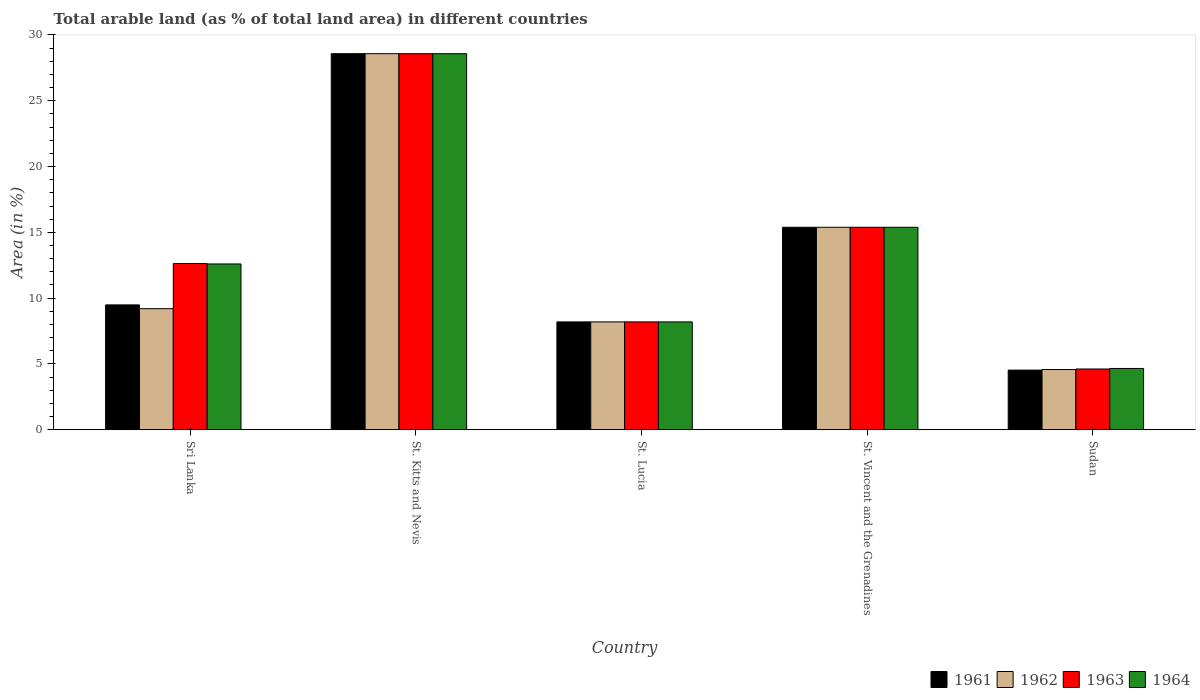How many different coloured bars are there?
Provide a succinct answer. 4. How many bars are there on the 2nd tick from the left?
Provide a succinct answer. 4. How many bars are there on the 5th tick from the right?
Provide a short and direct response. 4. What is the label of the 3rd group of bars from the left?
Provide a short and direct response. St. Lucia. What is the percentage of arable land in 1964 in Sri Lanka?
Provide a succinct answer. 12.6. Across all countries, what is the maximum percentage of arable land in 1963?
Offer a terse response. 28.57. Across all countries, what is the minimum percentage of arable land in 1962?
Your answer should be compact. 4.58. In which country was the percentage of arable land in 1964 maximum?
Provide a short and direct response. St. Kitts and Nevis. In which country was the percentage of arable land in 1962 minimum?
Your response must be concise. Sudan. What is the total percentage of arable land in 1963 in the graph?
Make the answer very short. 69.4. What is the difference between the percentage of arable land in 1962 in Sri Lanka and that in Sudan?
Give a very brief answer. 4.62. What is the difference between the percentage of arable land in 1962 in St. Lucia and the percentage of arable land in 1963 in Sudan?
Keep it short and to the point. 3.58. What is the average percentage of arable land in 1963 per country?
Ensure brevity in your answer.  13.88. What is the difference between the percentage of arable land of/in 1962 and percentage of arable land of/in 1964 in Sudan?
Keep it short and to the point. -0.08. In how many countries, is the percentage of arable land in 1963 greater than 9 %?
Keep it short and to the point. 3. What is the ratio of the percentage of arable land in 1961 in St. Vincent and the Grenadines to that in Sudan?
Offer a terse response. 3.39. Is the percentage of arable land in 1963 in St. Kitts and Nevis less than that in St. Lucia?
Offer a very short reply. No. What is the difference between the highest and the second highest percentage of arable land in 1963?
Keep it short and to the point. 15.94. What is the difference between the highest and the lowest percentage of arable land in 1963?
Give a very brief answer. 23.95. In how many countries, is the percentage of arable land in 1963 greater than the average percentage of arable land in 1963 taken over all countries?
Make the answer very short. 2. Is it the case that in every country, the sum of the percentage of arable land in 1963 and percentage of arable land in 1962 is greater than the sum of percentage of arable land in 1961 and percentage of arable land in 1964?
Your answer should be very brief. No. How many bars are there?
Give a very brief answer. 20. Are all the bars in the graph horizontal?
Provide a succinct answer. No. How many countries are there in the graph?
Make the answer very short. 5. Are the values on the major ticks of Y-axis written in scientific E-notation?
Ensure brevity in your answer.  No. Does the graph contain any zero values?
Your answer should be compact. No. Does the graph contain grids?
Provide a short and direct response. No. Where does the legend appear in the graph?
Keep it short and to the point. Bottom right. How are the legend labels stacked?
Your response must be concise. Horizontal. What is the title of the graph?
Your response must be concise. Total arable land (as % of total land area) in different countries. What is the label or title of the X-axis?
Provide a succinct answer. Country. What is the label or title of the Y-axis?
Give a very brief answer. Area (in %). What is the Area (in %) in 1961 in Sri Lanka?
Give a very brief answer. 9.49. What is the Area (in %) in 1962 in Sri Lanka?
Provide a succinct answer. 9.2. What is the Area (in %) of 1963 in Sri Lanka?
Ensure brevity in your answer.  12.63. What is the Area (in %) of 1964 in Sri Lanka?
Offer a terse response. 12.6. What is the Area (in %) of 1961 in St. Kitts and Nevis?
Keep it short and to the point. 28.57. What is the Area (in %) of 1962 in St. Kitts and Nevis?
Your answer should be compact. 28.57. What is the Area (in %) in 1963 in St. Kitts and Nevis?
Ensure brevity in your answer.  28.57. What is the Area (in %) of 1964 in St. Kitts and Nevis?
Offer a terse response. 28.57. What is the Area (in %) of 1961 in St. Lucia?
Offer a very short reply. 8.2. What is the Area (in %) in 1962 in St. Lucia?
Offer a very short reply. 8.2. What is the Area (in %) in 1963 in St. Lucia?
Give a very brief answer. 8.2. What is the Area (in %) of 1964 in St. Lucia?
Offer a terse response. 8.2. What is the Area (in %) of 1961 in St. Vincent and the Grenadines?
Ensure brevity in your answer.  15.38. What is the Area (in %) in 1962 in St. Vincent and the Grenadines?
Your response must be concise. 15.38. What is the Area (in %) of 1963 in St. Vincent and the Grenadines?
Give a very brief answer. 15.38. What is the Area (in %) in 1964 in St. Vincent and the Grenadines?
Give a very brief answer. 15.38. What is the Area (in %) of 1961 in Sudan?
Provide a succinct answer. 4.53. What is the Area (in %) in 1962 in Sudan?
Your response must be concise. 4.58. What is the Area (in %) of 1963 in Sudan?
Your answer should be very brief. 4.62. What is the Area (in %) of 1964 in Sudan?
Make the answer very short. 4.66. Across all countries, what is the maximum Area (in %) in 1961?
Ensure brevity in your answer.  28.57. Across all countries, what is the maximum Area (in %) of 1962?
Make the answer very short. 28.57. Across all countries, what is the maximum Area (in %) in 1963?
Offer a very short reply. 28.57. Across all countries, what is the maximum Area (in %) of 1964?
Your answer should be compact. 28.57. Across all countries, what is the minimum Area (in %) in 1961?
Your answer should be compact. 4.53. Across all countries, what is the minimum Area (in %) of 1962?
Keep it short and to the point. 4.58. Across all countries, what is the minimum Area (in %) of 1963?
Ensure brevity in your answer.  4.62. Across all countries, what is the minimum Area (in %) of 1964?
Your response must be concise. 4.66. What is the total Area (in %) in 1961 in the graph?
Your answer should be compact. 66.18. What is the total Area (in %) of 1962 in the graph?
Ensure brevity in your answer.  65.93. What is the total Area (in %) in 1963 in the graph?
Your answer should be compact. 69.4. What is the total Area (in %) in 1964 in the graph?
Provide a succinct answer. 69.41. What is the difference between the Area (in %) of 1961 in Sri Lanka and that in St. Kitts and Nevis?
Provide a short and direct response. -19.08. What is the difference between the Area (in %) in 1962 in Sri Lanka and that in St. Kitts and Nevis?
Offer a terse response. -19.37. What is the difference between the Area (in %) of 1963 in Sri Lanka and that in St. Kitts and Nevis?
Make the answer very short. -15.94. What is the difference between the Area (in %) of 1964 in Sri Lanka and that in St. Kitts and Nevis?
Your response must be concise. -15.97. What is the difference between the Area (in %) in 1961 in Sri Lanka and that in St. Lucia?
Provide a short and direct response. 1.29. What is the difference between the Area (in %) of 1963 in Sri Lanka and that in St. Lucia?
Offer a terse response. 4.43. What is the difference between the Area (in %) of 1964 in Sri Lanka and that in St. Lucia?
Ensure brevity in your answer.  4.4. What is the difference between the Area (in %) in 1961 in Sri Lanka and that in St. Vincent and the Grenadines?
Give a very brief answer. -5.9. What is the difference between the Area (in %) in 1962 in Sri Lanka and that in St. Vincent and the Grenadines?
Your answer should be compact. -6.18. What is the difference between the Area (in %) in 1963 in Sri Lanka and that in St. Vincent and the Grenadines?
Offer a very short reply. -2.76. What is the difference between the Area (in %) of 1964 in Sri Lanka and that in St. Vincent and the Grenadines?
Offer a terse response. -2.79. What is the difference between the Area (in %) in 1961 in Sri Lanka and that in Sudan?
Keep it short and to the point. 4.95. What is the difference between the Area (in %) of 1962 in Sri Lanka and that in Sudan?
Provide a succinct answer. 4.62. What is the difference between the Area (in %) of 1963 in Sri Lanka and that in Sudan?
Ensure brevity in your answer.  8.01. What is the difference between the Area (in %) in 1964 in Sri Lanka and that in Sudan?
Offer a terse response. 7.94. What is the difference between the Area (in %) of 1961 in St. Kitts and Nevis and that in St. Lucia?
Your response must be concise. 20.37. What is the difference between the Area (in %) of 1962 in St. Kitts and Nevis and that in St. Lucia?
Offer a very short reply. 20.37. What is the difference between the Area (in %) in 1963 in St. Kitts and Nevis and that in St. Lucia?
Offer a terse response. 20.37. What is the difference between the Area (in %) of 1964 in St. Kitts and Nevis and that in St. Lucia?
Ensure brevity in your answer.  20.37. What is the difference between the Area (in %) in 1961 in St. Kitts and Nevis and that in St. Vincent and the Grenadines?
Keep it short and to the point. 13.19. What is the difference between the Area (in %) of 1962 in St. Kitts and Nevis and that in St. Vincent and the Grenadines?
Your response must be concise. 13.19. What is the difference between the Area (in %) in 1963 in St. Kitts and Nevis and that in St. Vincent and the Grenadines?
Your answer should be very brief. 13.19. What is the difference between the Area (in %) of 1964 in St. Kitts and Nevis and that in St. Vincent and the Grenadines?
Your response must be concise. 13.19. What is the difference between the Area (in %) in 1961 in St. Kitts and Nevis and that in Sudan?
Make the answer very short. 24.04. What is the difference between the Area (in %) in 1962 in St. Kitts and Nevis and that in Sudan?
Provide a short and direct response. 23.99. What is the difference between the Area (in %) of 1963 in St. Kitts and Nevis and that in Sudan?
Offer a very short reply. 23.95. What is the difference between the Area (in %) of 1964 in St. Kitts and Nevis and that in Sudan?
Your answer should be very brief. 23.91. What is the difference between the Area (in %) of 1961 in St. Lucia and that in St. Vincent and the Grenadines?
Offer a terse response. -7.19. What is the difference between the Area (in %) in 1962 in St. Lucia and that in St. Vincent and the Grenadines?
Provide a short and direct response. -7.19. What is the difference between the Area (in %) of 1963 in St. Lucia and that in St. Vincent and the Grenadines?
Offer a terse response. -7.19. What is the difference between the Area (in %) of 1964 in St. Lucia and that in St. Vincent and the Grenadines?
Provide a succinct answer. -7.19. What is the difference between the Area (in %) of 1961 in St. Lucia and that in Sudan?
Offer a very short reply. 3.66. What is the difference between the Area (in %) of 1962 in St. Lucia and that in Sudan?
Make the answer very short. 3.62. What is the difference between the Area (in %) of 1963 in St. Lucia and that in Sudan?
Ensure brevity in your answer.  3.58. What is the difference between the Area (in %) in 1964 in St. Lucia and that in Sudan?
Give a very brief answer. 3.54. What is the difference between the Area (in %) of 1961 in St. Vincent and the Grenadines and that in Sudan?
Provide a succinct answer. 10.85. What is the difference between the Area (in %) in 1962 in St. Vincent and the Grenadines and that in Sudan?
Make the answer very short. 10.81. What is the difference between the Area (in %) of 1963 in St. Vincent and the Grenadines and that in Sudan?
Ensure brevity in your answer.  10.77. What is the difference between the Area (in %) of 1964 in St. Vincent and the Grenadines and that in Sudan?
Your response must be concise. 10.72. What is the difference between the Area (in %) of 1961 in Sri Lanka and the Area (in %) of 1962 in St. Kitts and Nevis?
Keep it short and to the point. -19.08. What is the difference between the Area (in %) in 1961 in Sri Lanka and the Area (in %) in 1963 in St. Kitts and Nevis?
Offer a very short reply. -19.08. What is the difference between the Area (in %) of 1961 in Sri Lanka and the Area (in %) of 1964 in St. Kitts and Nevis?
Your answer should be compact. -19.08. What is the difference between the Area (in %) of 1962 in Sri Lanka and the Area (in %) of 1963 in St. Kitts and Nevis?
Provide a short and direct response. -19.37. What is the difference between the Area (in %) in 1962 in Sri Lanka and the Area (in %) in 1964 in St. Kitts and Nevis?
Provide a succinct answer. -19.37. What is the difference between the Area (in %) in 1963 in Sri Lanka and the Area (in %) in 1964 in St. Kitts and Nevis?
Give a very brief answer. -15.94. What is the difference between the Area (in %) in 1961 in Sri Lanka and the Area (in %) in 1962 in St. Lucia?
Provide a succinct answer. 1.29. What is the difference between the Area (in %) in 1961 in Sri Lanka and the Area (in %) in 1963 in St. Lucia?
Make the answer very short. 1.29. What is the difference between the Area (in %) of 1961 in Sri Lanka and the Area (in %) of 1964 in St. Lucia?
Make the answer very short. 1.29. What is the difference between the Area (in %) of 1962 in Sri Lanka and the Area (in %) of 1963 in St. Lucia?
Give a very brief answer. 1. What is the difference between the Area (in %) of 1962 in Sri Lanka and the Area (in %) of 1964 in St. Lucia?
Your response must be concise. 1. What is the difference between the Area (in %) of 1963 in Sri Lanka and the Area (in %) of 1964 in St. Lucia?
Make the answer very short. 4.43. What is the difference between the Area (in %) of 1961 in Sri Lanka and the Area (in %) of 1962 in St. Vincent and the Grenadines?
Your answer should be very brief. -5.9. What is the difference between the Area (in %) in 1961 in Sri Lanka and the Area (in %) in 1963 in St. Vincent and the Grenadines?
Ensure brevity in your answer.  -5.9. What is the difference between the Area (in %) in 1961 in Sri Lanka and the Area (in %) in 1964 in St. Vincent and the Grenadines?
Your answer should be very brief. -5.9. What is the difference between the Area (in %) of 1962 in Sri Lanka and the Area (in %) of 1963 in St. Vincent and the Grenadines?
Provide a short and direct response. -6.18. What is the difference between the Area (in %) of 1962 in Sri Lanka and the Area (in %) of 1964 in St. Vincent and the Grenadines?
Ensure brevity in your answer.  -6.18. What is the difference between the Area (in %) in 1963 in Sri Lanka and the Area (in %) in 1964 in St. Vincent and the Grenadines?
Your answer should be compact. -2.76. What is the difference between the Area (in %) in 1961 in Sri Lanka and the Area (in %) in 1962 in Sudan?
Give a very brief answer. 4.91. What is the difference between the Area (in %) in 1961 in Sri Lanka and the Area (in %) in 1963 in Sudan?
Your response must be concise. 4.87. What is the difference between the Area (in %) of 1961 in Sri Lanka and the Area (in %) of 1964 in Sudan?
Ensure brevity in your answer.  4.83. What is the difference between the Area (in %) of 1962 in Sri Lanka and the Area (in %) of 1963 in Sudan?
Your answer should be very brief. 4.58. What is the difference between the Area (in %) in 1962 in Sri Lanka and the Area (in %) in 1964 in Sudan?
Offer a very short reply. 4.54. What is the difference between the Area (in %) in 1963 in Sri Lanka and the Area (in %) in 1964 in Sudan?
Provide a succinct answer. 7.97. What is the difference between the Area (in %) of 1961 in St. Kitts and Nevis and the Area (in %) of 1962 in St. Lucia?
Give a very brief answer. 20.37. What is the difference between the Area (in %) of 1961 in St. Kitts and Nevis and the Area (in %) of 1963 in St. Lucia?
Offer a very short reply. 20.37. What is the difference between the Area (in %) of 1961 in St. Kitts and Nevis and the Area (in %) of 1964 in St. Lucia?
Keep it short and to the point. 20.37. What is the difference between the Area (in %) in 1962 in St. Kitts and Nevis and the Area (in %) in 1963 in St. Lucia?
Your answer should be very brief. 20.37. What is the difference between the Area (in %) of 1962 in St. Kitts and Nevis and the Area (in %) of 1964 in St. Lucia?
Make the answer very short. 20.37. What is the difference between the Area (in %) of 1963 in St. Kitts and Nevis and the Area (in %) of 1964 in St. Lucia?
Keep it short and to the point. 20.37. What is the difference between the Area (in %) in 1961 in St. Kitts and Nevis and the Area (in %) in 1962 in St. Vincent and the Grenadines?
Offer a terse response. 13.19. What is the difference between the Area (in %) in 1961 in St. Kitts and Nevis and the Area (in %) in 1963 in St. Vincent and the Grenadines?
Keep it short and to the point. 13.19. What is the difference between the Area (in %) of 1961 in St. Kitts and Nevis and the Area (in %) of 1964 in St. Vincent and the Grenadines?
Offer a terse response. 13.19. What is the difference between the Area (in %) of 1962 in St. Kitts and Nevis and the Area (in %) of 1963 in St. Vincent and the Grenadines?
Your answer should be very brief. 13.19. What is the difference between the Area (in %) of 1962 in St. Kitts and Nevis and the Area (in %) of 1964 in St. Vincent and the Grenadines?
Provide a succinct answer. 13.19. What is the difference between the Area (in %) of 1963 in St. Kitts and Nevis and the Area (in %) of 1964 in St. Vincent and the Grenadines?
Offer a very short reply. 13.19. What is the difference between the Area (in %) in 1961 in St. Kitts and Nevis and the Area (in %) in 1962 in Sudan?
Provide a succinct answer. 23.99. What is the difference between the Area (in %) in 1961 in St. Kitts and Nevis and the Area (in %) in 1963 in Sudan?
Your answer should be very brief. 23.95. What is the difference between the Area (in %) in 1961 in St. Kitts and Nevis and the Area (in %) in 1964 in Sudan?
Keep it short and to the point. 23.91. What is the difference between the Area (in %) of 1962 in St. Kitts and Nevis and the Area (in %) of 1963 in Sudan?
Your answer should be very brief. 23.95. What is the difference between the Area (in %) of 1962 in St. Kitts and Nevis and the Area (in %) of 1964 in Sudan?
Provide a short and direct response. 23.91. What is the difference between the Area (in %) of 1963 in St. Kitts and Nevis and the Area (in %) of 1964 in Sudan?
Ensure brevity in your answer.  23.91. What is the difference between the Area (in %) of 1961 in St. Lucia and the Area (in %) of 1962 in St. Vincent and the Grenadines?
Make the answer very short. -7.19. What is the difference between the Area (in %) in 1961 in St. Lucia and the Area (in %) in 1963 in St. Vincent and the Grenadines?
Keep it short and to the point. -7.19. What is the difference between the Area (in %) in 1961 in St. Lucia and the Area (in %) in 1964 in St. Vincent and the Grenadines?
Your response must be concise. -7.19. What is the difference between the Area (in %) in 1962 in St. Lucia and the Area (in %) in 1963 in St. Vincent and the Grenadines?
Provide a succinct answer. -7.19. What is the difference between the Area (in %) of 1962 in St. Lucia and the Area (in %) of 1964 in St. Vincent and the Grenadines?
Give a very brief answer. -7.19. What is the difference between the Area (in %) of 1963 in St. Lucia and the Area (in %) of 1964 in St. Vincent and the Grenadines?
Make the answer very short. -7.19. What is the difference between the Area (in %) in 1961 in St. Lucia and the Area (in %) in 1962 in Sudan?
Keep it short and to the point. 3.62. What is the difference between the Area (in %) of 1961 in St. Lucia and the Area (in %) of 1963 in Sudan?
Make the answer very short. 3.58. What is the difference between the Area (in %) in 1961 in St. Lucia and the Area (in %) in 1964 in Sudan?
Provide a succinct answer. 3.54. What is the difference between the Area (in %) of 1962 in St. Lucia and the Area (in %) of 1963 in Sudan?
Ensure brevity in your answer.  3.58. What is the difference between the Area (in %) of 1962 in St. Lucia and the Area (in %) of 1964 in Sudan?
Make the answer very short. 3.54. What is the difference between the Area (in %) in 1963 in St. Lucia and the Area (in %) in 1964 in Sudan?
Give a very brief answer. 3.54. What is the difference between the Area (in %) of 1961 in St. Vincent and the Grenadines and the Area (in %) of 1962 in Sudan?
Provide a short and direct response. 10.81. What is the difference between the Area (in %) of 1961 in St. Vincent and the Grenadines and the Area (in %) of 1963 in Sudan?
Offer a very short reply. 10.77. What is the difference between the Area (in %) in 1961 in St. Vincent and the Grenadines and the Area (in %) in 1964 in Sudan?
Give a very brief answer. 10.72. What is the difference between the Area (in %) in 1962 in St. Vincent and the Grenadines and the Area (in %) in 1963 in Sudan?
Provide a short and direct response. 10.77. What is the difference between the Area (in %) in 1962 in St. Vincent and the Grenadines and the Area (in %) in 1964 in Sudan?
Provide a succinct answer. 10.72. What is the difference between the Area (in %) of 1963 in St. Vincent and the Grenadines and the Area (in %) of 1964 in Sudan?
Provide a short and direct response. 10.72. What is the average Area (in %) in 1961 per country?
Make the answer very short. 13.24. What is the average Area (in %) in 1962 per country?
Provide a short and direct response. 13.19. What is the average Area (in %) in 1963 per country?
Your response must be concise. 13.88. What is the average Area (in %) in 1964 per country?
Ensure brevity in your answer.  13.88. What is the difference between the Area (in %) of 1961 and Area (in %) of 1962 in Sri Lanka?
Your answer should be very brief. 0.29. What is the difference between the Area (in %) of 1961 and Area (in %) of 1963 in Sri Lanka?
Provide a short and direct response. -3.14. What is the difference between the Area (in %) in 1961 and Area (in %) in 1964 in Sri Lanka?
Provide a short and direct response. -3.11. What is the difference between the Area (in %) of 1962 and Area (in %) of 1963 in Sri Lanka?
Give a very brief answer. -3.43. What is the difference between the Area (in %) of 1962 and Area (in %) of 1964 in Sri Lanka?
Ensure brevity in your answer.  -3.4. What is the difference between the Area (in %) in 1963 and Area (in %) in 1964 in Sri Lanka?
Offer a very short reply. 0.03. What is the difference between the Area (in %) of 1961 and Area (in %) of 1963 in St. Kitts and Nevis?
Offer a terse response. 0. What is the difference between the Area (in %) of 1961 and Area (in %) of 1964 in St. Kitts and Nevis?
Offer a terse response. 0. What is the difference between the Area (in %) in 1962 and Area (in %) in 1964 in St. Lucia?
Provide a short and direct response. 0. What is the difference between the Area (in %) of 1963 and Area (in %) of 1964 in St. Lucia?
Provide a succinct answer. 0. What is the difference between the Area (in %) of 1961 and Area (in %) of 1963 in St. Vincent and the Grenadines?
Make the answer very short. 0. What is the difference between the Area (in %) of 1961 and Area (in %) of 1964 in St. Vincent and the Grenadines?
Provide a succinct answer. 0. What is the difference between the Area (in %) of 1962 and Area (in %) of 1963 in St. Vincent and the Grenadines?
Your response must be concise. 0. What is the difference between the Area (in %) of 1963 and Area (in %) of 1964 in St. Vincent and the Grenadines?
Give a very brief answer. 0. What is the difference between the Area (in %) of 1961 and Area (in %) of 1962 in Sudan?
Make the answer very short. -0.04. What is the difference between the Area (in %) in 1961 and Area (in %) in 1963 in Sudan?
Keep it short and to the point. -0.08. What is the difference between the Area (in %) in 1961 and Area (in %) in 1964 in Sudan?
Give a very brief answer. -0.12. What is the difference between the Area (in %) in 1962 and Area (in %) in 1963 in Sudan?
Make the answer very short. -0.04. What is the difference between the Area (in %) in 1962 and Area (in %) in 1964 in Sudan?
Ensure brevity in your answer.  -0.08. What is the difference between the Area (in %) in 1963 and Area (in %) in 1964 in Sudan?
Ensure brevity in your answer.  -0.04. What is the ratio of the Area (in %) of 1961 in Sri Lanka to that in St. Kitts and Nevis?
Your answer should be compact. 0.33. What is the ratio of the Area (in %) of 1962 in Sri Lanka to that in St. Kitts and Nevis?
Offer a very short reply. 0.32. What is the ratio of the Area (in %) of 1963 in Sri Lanka to that in St. Kitts and Nevis?
Your response must be concise. 0.44. What is the ratio of the Area (in %) in 1964 in Sri Lanka to that in St. Kitts and Nevis?
Your response must be concise. 0.44. What is the ratio of the Area (in %) in 1961 in Sri Lanka to that in St. Lucia?
Ensure brevity in your answer.  1.16. What is the ratio of the Area (in %) in 1962 in Sri Lanka to that in St. Lucia?
Offer a very short reply. 1.12. What is the ratio of the Area (in %) of 1963 in Sri Lanka to that in St. Lucia?
Give a very brief answer. 1.54. What is the ratio of the Area (in %) of 1964 in Sri Lanka to that in St. Lucia?
Offer a terse response. 1.54. What is the ratio of the Area (in %) of 1961 in Sri Lanka to that in St. Vincent and the Grenadines?
Your response must be concise. 0.62. What is the ratio of the Area (in %) in 1962 in Sri Lanka to that in St. Vincent and the Grenadines?
Ensure brevity in your answer.  0.6. What is the ratio of the Area (in %) of 1963 in Sri Lanka to that in St. Vincent and the Grenadines?
Your answer should be very brief. 0.82. What is the ratio of the Area (in %) in 1964 in Sri Lanka to that in St. Vincent and the Grenadines?
Offer a very short reply. 0.82. What is the ratio of the Area (in %) of 1961 in Sri Lanka to that in Sudan?
Offer a terse response. 2.09. What is the ratio of the Area (in %) of 1962 in Sri Lanka to that in Sudan?
Your answer should be very brief. 2.01. What is the ratio of the Area (in %) of 1963 in Sri Lanka to that in Sudan?
Give a very brief answer. 2.73. What is the ratio of the Area (in %) in 1964 in Sri Lanka to that in Sudan?
Make the answer very short. 2.7. What is the ratio of the Area (in %) of 1961 in St. Kitts and Nevis to that in St. Lucia?
Give a very brief answer. 3.49. What is the ratio of the Area (in %) of 1962 in St. Kitts and Nevis to that in St. Lucia?
Offer a very short reply. 3.49. What is the ratio of the Area (in %) of 1963 in St. Kitts and Nevis to that in St. Lucia?
Give a very brief answer. 3.49. What is the ratio of the Area (in %) in 1964 in St. Kitts and Nevis to that in St. Lucia?
Offer a terse response. 3.49. What is the ratio of the Area (in %) of 1961 in St. Kitts and Nevis to that in St. Vincent and the Grenadines?
Keep it short and to the point. 1.86. What is the ratio of the Area (in %) in 1962 in St. Kitts and Nevis to that in St. Vincent and the Grenadines?
Give a very brief answer. 1.86. What is the ratio of the Area (in %) in 1963 in St. Kitts and Nevis to that in St. Vincent and the Grenadines?
Offer a terse response. 1.86. What is the ratio of the Area (in %) of 1964 in St. Kitts and Nevis to that in St. Vincent and the Grenadines?
Offer a very short reply. 1.86. What is the ratio of the Area (in %) of 1961 in St. Kitts and Nevis to that in Sudan?
Offer a terse response. 6.3. What is the ratio of the Area (in %) of 1962 in St. Kitts and Nevis to that in Sudan?
Provide a short and direct response. 6.24. What is the ratio of the Area (in %) in 1963 in St. Kitts and Nevis to that in Sudan?
Provide a succinct answer. 6.19. What is the ratio of the Area (in %) of 1964 in St. Kitts and Nevis to that in Sudan?
Provide a short and direct response. 6.13. What is the ratio of the Area (in %) of 1961 in St. Lucia to that in St. Vincent and the Grenadines?
Offer a terse response. 0.53. What is the ratio of the Area (in %) of 1962 in St. Lucia to that in St. Vincent and the Grenadines?
Provide a short and direct response. 0.53. What is the ratio of the Area (in %) of 1963 in St. Lucia to that in St. Vincent and the Grenadines?
Provide a succinct answer. 0.53. What is the ratio of the Area (in %) in 1964 in St. Lucia to that in St. Vincent and the Grenadines?
Your response must be concise. 0.53. What is the ratio of the Area (in %) in 1961 in St. Lucia to that in Sudan?
Keep it short and to the point. 1.81. What is the ratio of the Area (in %) in 1962 in St. Lucia to that in Sudan?
Your response must be concise. 1.79. What is the ratio of the Area (in %) of 1963 in St. Lucia to that in Sudan?
Make the answer very short. 1.77. What is the ratio of the Area (in %) in 1964 in St. Lucia to that in Sudan?
Provide a short and direct response. 1.76. What is the ratio of the Area (in %) in 1961 in St. Vincent and the Grenadines to that in Sudan?
Provide a succinct answer. 3.39. What is the ratio of the Area (in %) of 1962 in St. Vincent and the Grenadines to that in Sudan?
Provide a short and direct response. 3.36. What is the ratio of the Area (in %) of 1963 in St. Vincent and the Grenadines to that in Sudan?
Your answer should be very brief. 3.33. What is the ratio of the Area (in %) in 1964 in St. Vincent and the Grenadines to that in Sudan?
Provide a succinct answer. 3.3. What is the difference between the highest and the second highest Area (in %) in 1961?
Ensure brevity in your answer.  13.19. What is the difference between the highest and the second highest Area (in %) in 1962?
Give a very brief answer. 13.19. What is the difference between the highest and the second highest Area (in %) of 1963?
Your answer should be very brief. 13.19. What is the difference between the highest and the second highest Area (in %) of 1964?
Provide a short and direct response. 13.19. What is the difference between the highest and the lowest Area (in %) in 1961?
Provide a succinct answer. 24.04. What is the difference between the highest and the lowest Area (in %) in 1962?
Give a very brief answer. 23.99. What is the difference between the highest and the lowest Area (in %) of 1963?
Offer a very short reply. 23.95. What is the difference between the highest and the lowest Area (in %) of 1964?
Offer a terse response. 23.91. 